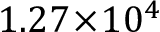Convert formula to latex. <formula><loc_0><loc_0><loc_500><loc_500>1 . 2 7 \, \times \, 1 0 ^ { 4 }</formula> 